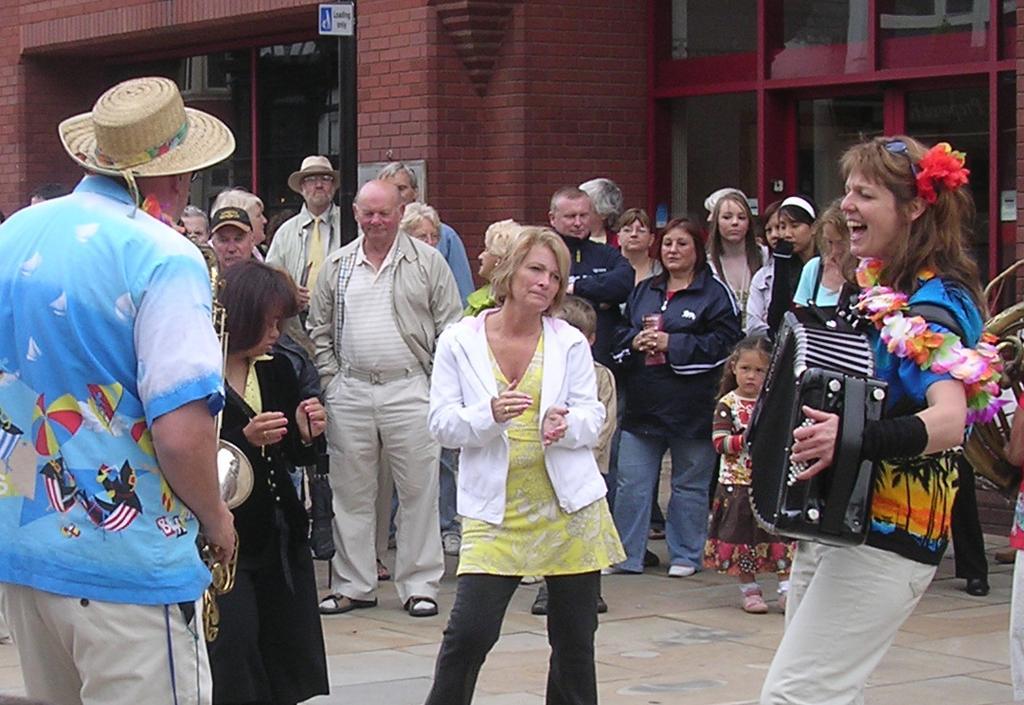Please provide a concise description of this image. In this image there is a woman at the right side of image is playing an accordion is wearing a summer suit. Person at the left side is playing saxophone is wearing a summer suit. There are group of people standing and listening music. Woman at the middle of image is wearing yellow colour top is dancing. At the background there is a red brick wall. 